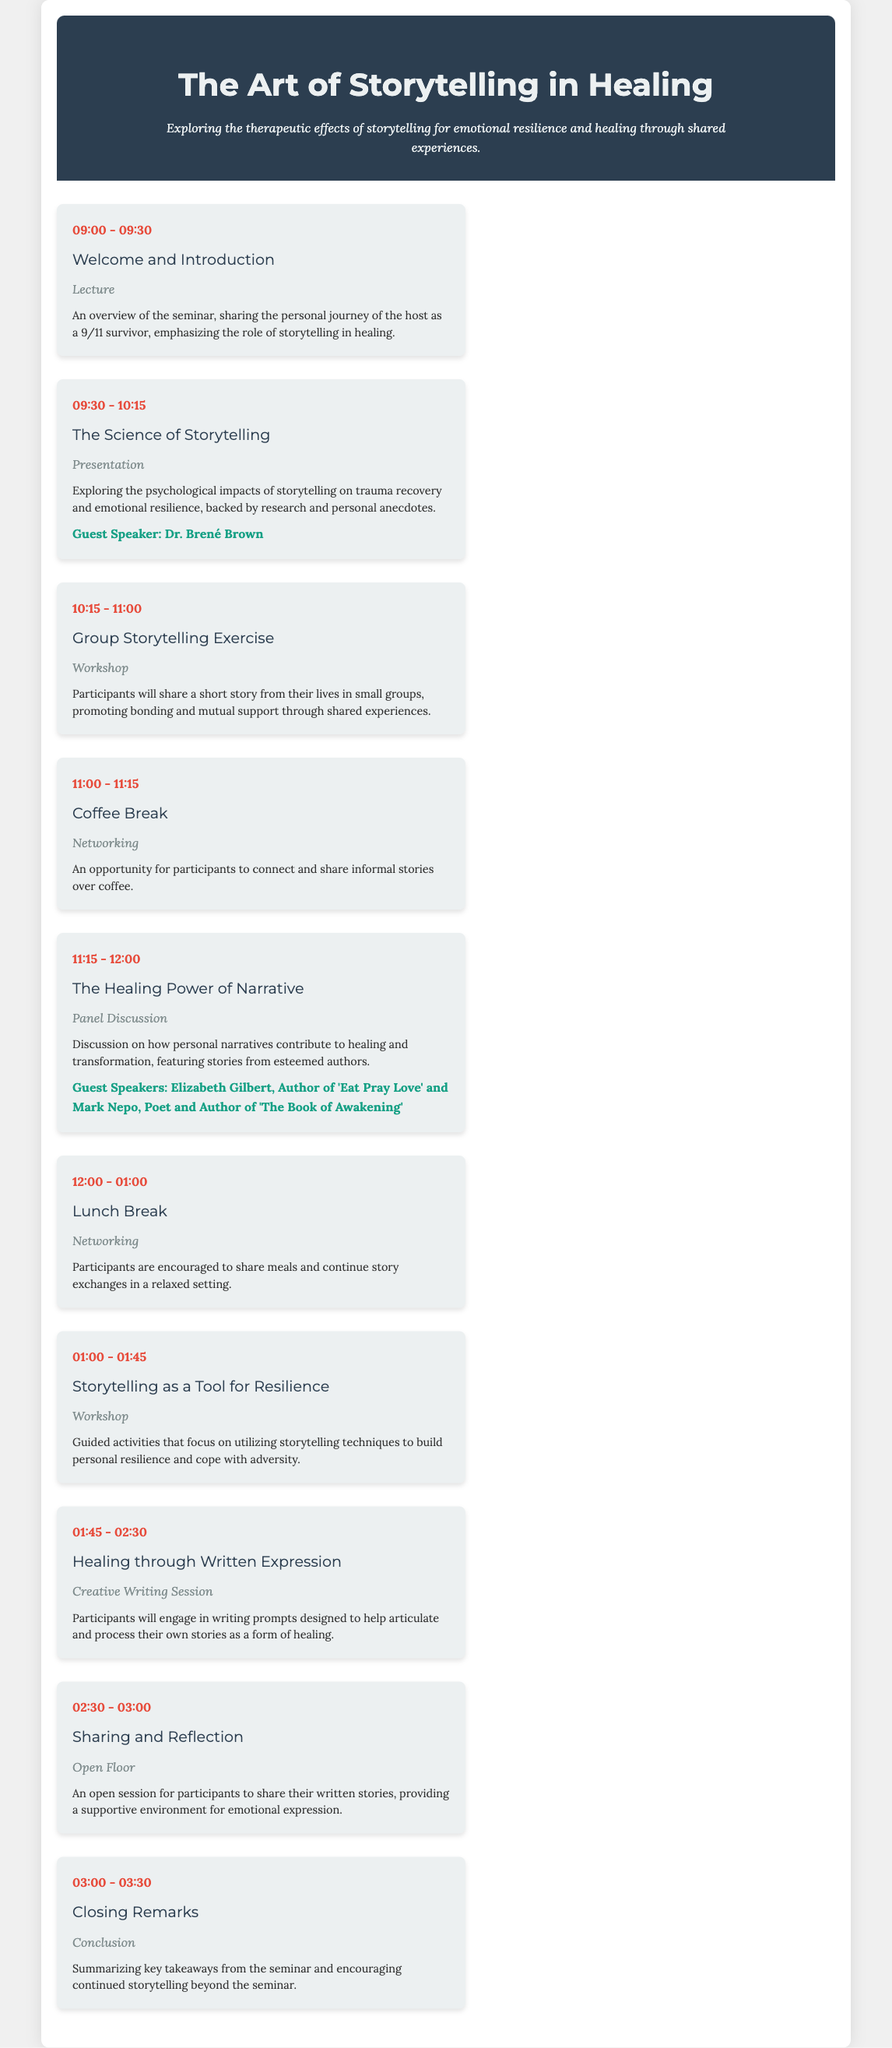what is the title of the seminar? The title of the seminar is prominently stated at the beginning of the document.
Answer: The Art of Storytelling in Healing who is the guest speaker for "The Science of Storytelling" session? This information is provided under the session description for "The Science of Storytelling."
Answer: Dr. Brené Brown what is the duration of the lunch break? The duration of the lunch break is specified in the agenda as an hour.
Answer: 01:00 what type of session is "Healing through Written Expression"? The format of the session is clearly mentioned under each session title.
Answer: Creative Writing Session which session features Elizabeth Gilbert as a guest speaker? This detail is mentioned in relation to the panel discussion about healing personal narratives.
Answer: The Healing Power of Narrative how many guest speakers are featured throughout the seminar? The document includes specific mentions of guest speakers in several sessions.
Answer: Three what is the main theme of this seminar? The overarching theme is articulated in the description at the top of the document.
Answer: Therapeutic effects of storytelling what is the start time of the seminar? The start time is indicated at the beginning of the agenda sessions.
Answer: 09:00 what type of session is scheduled right after the coffee break? The session following the coffee break is identified by its format.
Answer: Panel Discussion 